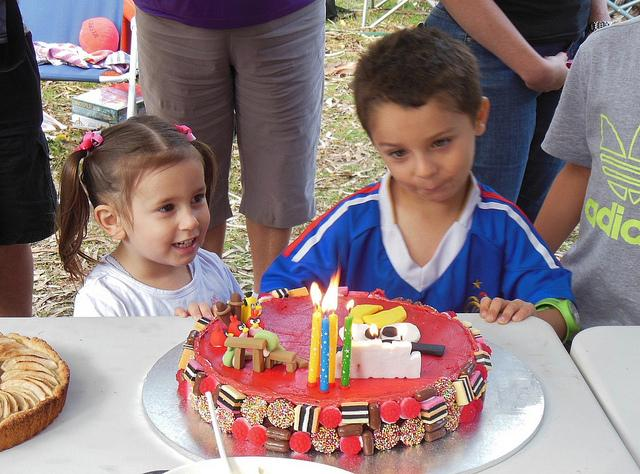When will this girl be old enough for Kindergarten? five 